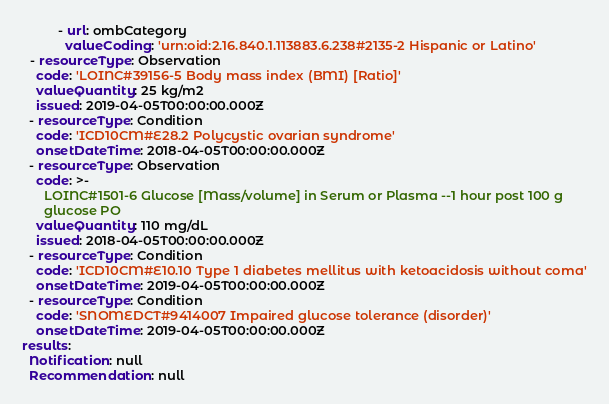<code> <loc_0><loc_0><loc_500><loc_500><_YAML_>          - url: ombCategory
            valueCoding: 'urn:oid:2.16.840.1.113883.6.238#2135-2 Hispanic or Latino'
  - resourceType: Observation
    code: 'LOINC#39156-5 Body mass index (BMI) [Ratio]'
    valueQuantity: 25 kg/m2
    issued: 2019-04-05T00:00:00.000Z
  - resourceType: Condition
    code: 'ICD10CM#E28.2 Polycystic ovarian syndrome'
    onsetDateTime: 2018-04-05T00:00:00.000Z
  - resourceType: Observation
    code: >-
      LOINC#1501-6 Glucose [Mass/volume] in Serum or Plasma --1 hour post 100 g
      glucose PO
    valueQuantity: 110 mg/dL
    issued: 2018-04-05T00:00:00.000Z
  - resourceType: Condition
    code: 'ICD10CM#E10.10 Type 1 diabetes mellitus with ketoacidosis without coma'
    onsetDateTime: 2019-04-05T00:00:00.000Z
  - resourceType: Condition
    code: 'SNOMEDCT#9414007 Impaired glucose tolerance (disorder)'
    onsetDateTime: 2019-04-05T00:00:00.000Z
results:
  Notification: null
  Recommendation: null
</code> 